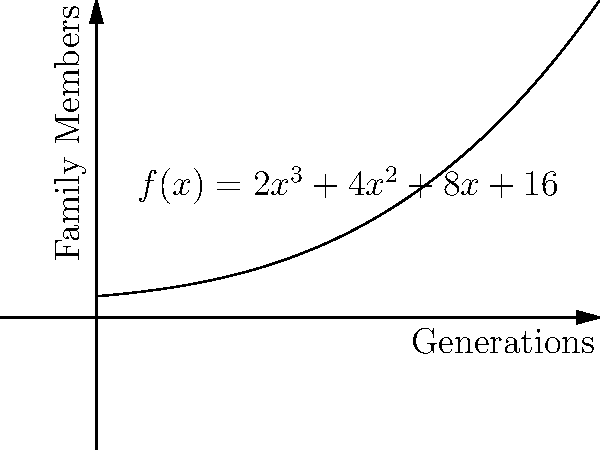As a genealogy enthusiast, you've modeled your family tree growth using the polynomial function $f(x) = 2x^3 + 4x^2 + 8x + 16$, where $x$ represents the number of generations and $f(x)$ represents the total number of family members. How many new family members are added in the 4th generation? To find the number of new family members added in the 4th generation, we need to:

1. Calculate the total number of family members at the 3rd generation: $f(3)$
2. Calculate the total number of family members at the 4th generation: $f(4)$
3. Subtract $f(3)$ from $f(4)$ to get the number of new members added

Step 1: Calculate $f(3)$
$f(3) = 2(3)^3 + 4(3)^2 + 8(3) + 16$
$f(3) = 2(27) + 4(9) + 24 + 16$
$f(3) = 54 + 36 + 24 + 16 = 130$

Step 2: Calculate $f(4)$
$f(4) = 2(4)^3 + 4(4)^2 + 8(4) + 16$
$f(4) = 2(64) + 4(16) + 32 + 16$
$f(4) = 128 + 64 + 32 + 16 = 240$

Step 3: Subtract $f(3)$ from $f(4)$
New members added = $f(4) - f(3) = 240 - 130 = 110$

Therefore, 110 new family members are added in the 4th generation.
Answer: 110 